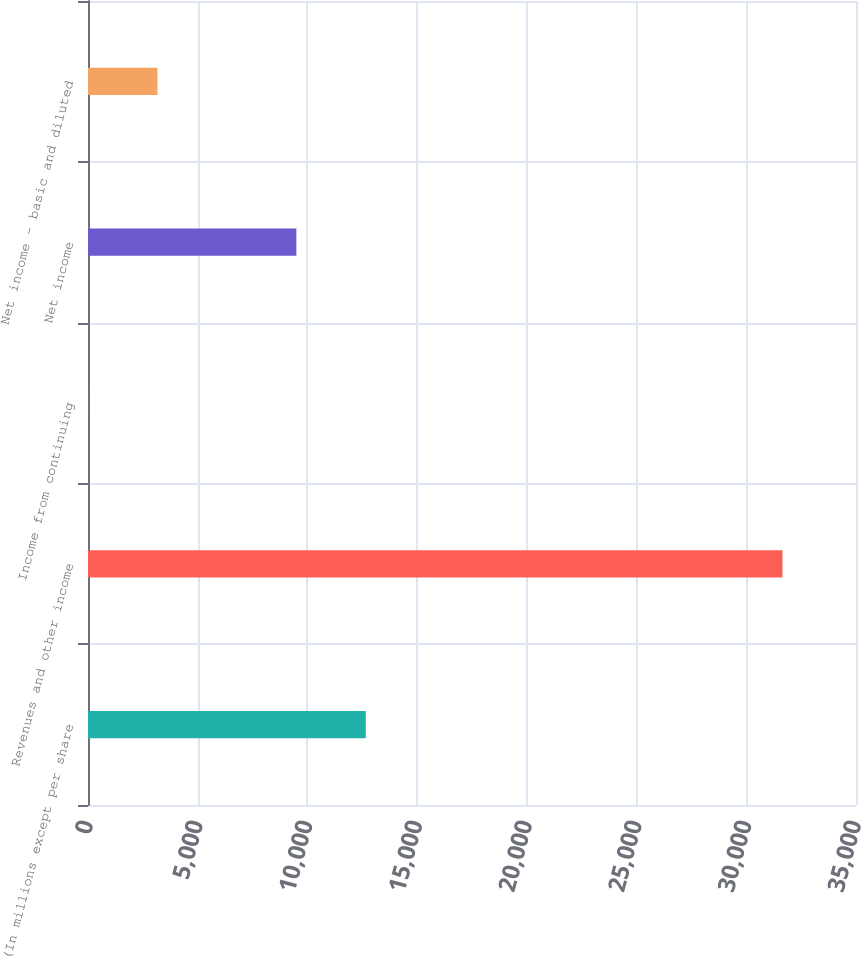Convert chart to OTSL. <chart><loc_0><loc_0><loc_500><loc_500><bar_chart><fcel>(In millions except per share<fcel>Revenues and other income<fcel>Income from continuing<fcel>Net income<fcel>Net income - basic and diluted<nl><fcel>12660.2<fcel>31648<fcel>1.63<fcel>9495.55<fcel>3166.27<nl></chart> 